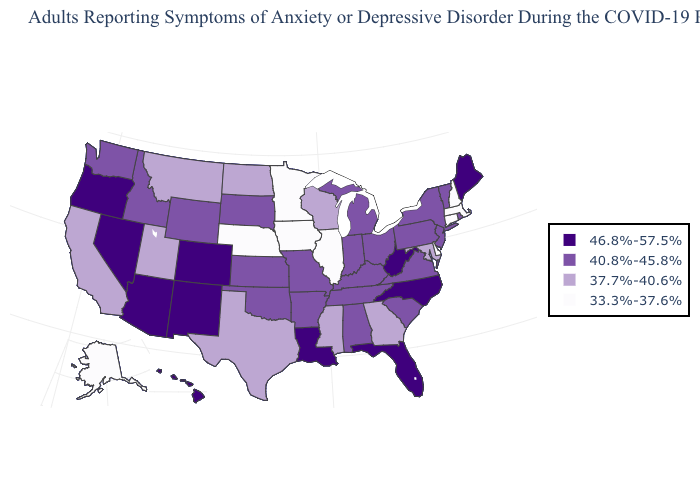Name the states that have a value in the range 37.7%-40.6%?
Concise answer only. California, Georgia, Maryland, Mississippi, Montana, North Dakota, Texas, Utah, Wisconsin. What is the value of Arkansas?
Be succinct. 40.8%-45.8%. What is the value of Colorado?
Answer briefly. 46.8%-57.5%. Does Mississippi have the lowest value in the South?
Quick response, please. No. Does Massachusetts have the same value as Iowa?
Short answer required. Yes. Does Kentucky have a lower value than New Mexico?
Give a very brief answer. Yes. Name the states that have a value in the range 37.7%-40.6%?
Concise answer only. California, Georgia, Maryland, Mississippi, Montana, North Dakota, Texas, Utah, Wisconsin. Name the states that have a value in the range 33.3%-37.6%?
Write a very short answer. Alaska, Connecticut, Delaware, Illinois, Iowa, Massachusetts, Minnesota, Nebraska, New Hampshire. What is the value of Vermont?
Be succinct. 40.8%-45.8%. Which states hav the highest value in the MidWest?
Give a very brief answer. Indiana, Kansas, Michigan, Missouri, Ohio, South Dakota. Does Florida have the highest value in the South?
Give a very brief answer. Yes. Name the states that have a value in the range 46.8%-57.5%?
Concise answer only. Arizona, Colorado, Florida, Hawaii, Louisiana, Maine, Nevada, New Mexico, North Carolina, Oregon, West Virginia. Name the states that have a value in the range 37.7%-40.6%?
Be succinct. California, Georgia, Maryland, Mississippi, Montana, North Dakota, Texas, Utah, Wisconsin. What is the highest value in states that border Mississippi?
Quick response, please. 46.8%-57.5%. 